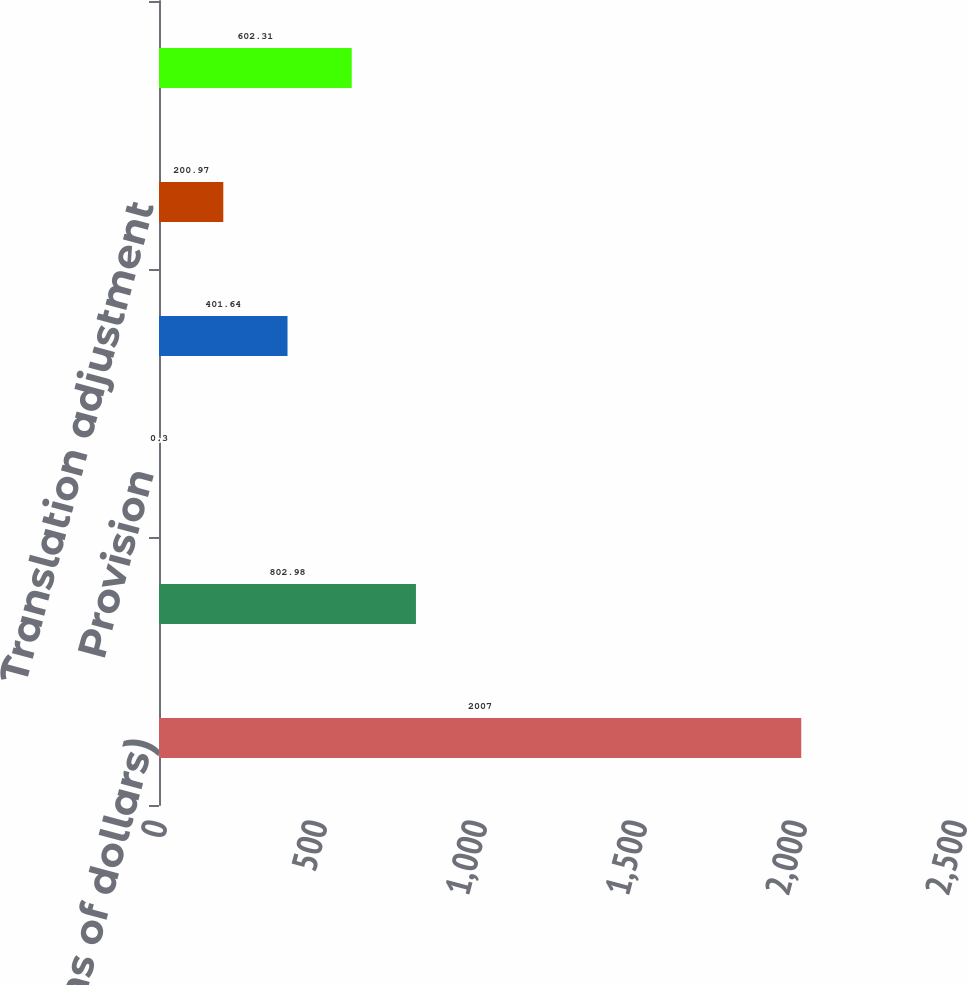<chart> <loc_0><loc_0><loc_500><loc_500><bar_chart><fcel>(millions of dollars)<fcel>Beginning balance<fcel>Provision<fcel>Write-offs<fcel>Translation adjustment<fcel>Ending balance<nl><fcel>2007<fcel>802.98<fcel>0.3<fcel>401.64<fcel>200.97<fcel>602.31<nl></chart> 